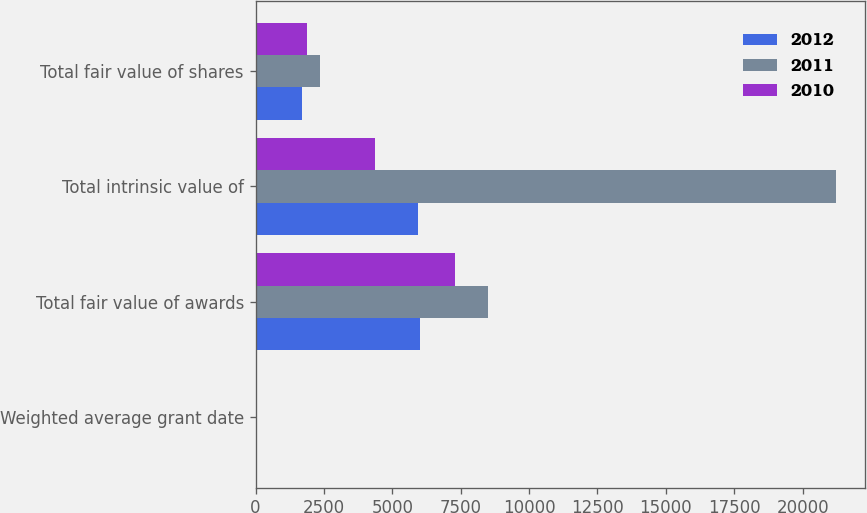Convert chart to OTSL. <chart><loc_0><loc_0><loc_500><loc_500><stacked_bar_chart><ecel><fcel>Weighted average grant date<fcel>Total fair value of awards<fcel>Total intrinsic value of<fcel>Total fair value of shares<nl><fcel>2012<fcel>6.43<fcel>6023<fcel>5928<fcel>1694<nl><fcel>2011<fcel>11.61<fcel>8492<fcel>21234<fcel>2359<nl><fcel>2010<fcel>11.52<fcel>7281<fcel>4358.5<fcel>1885<nl></chart> 